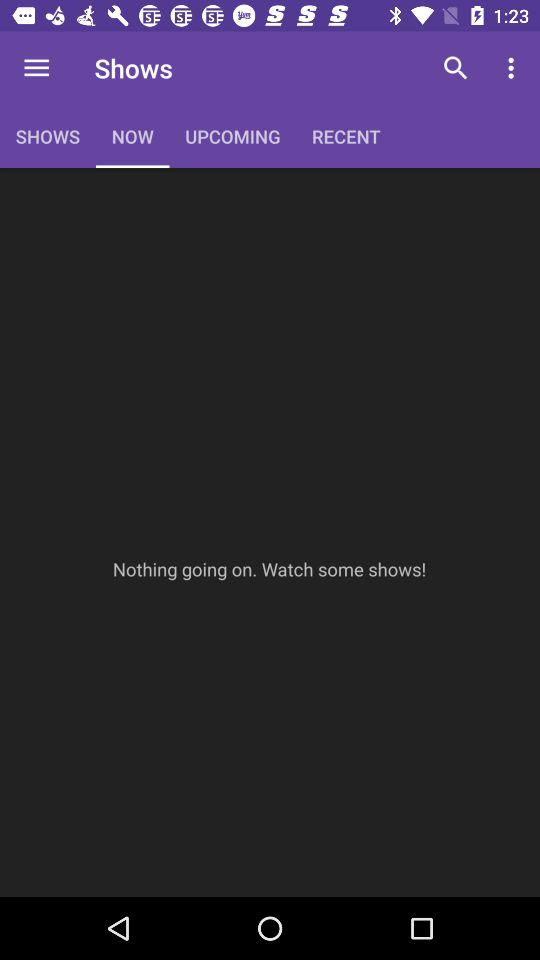Is there a show going on? There is nothing going on. 